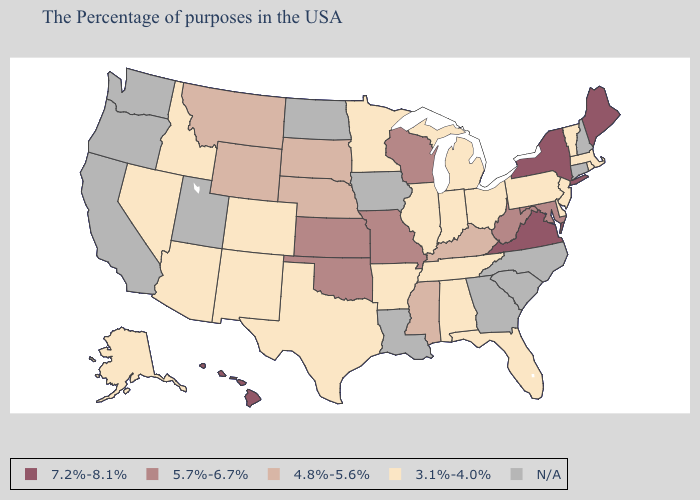Is the legend a continuous bar?
Concise answer only. No. What is the lowest value in states that border Iowa?
Write a very short answer. 3.1%-4.0%. What is the lowest value in states that border Rhode Island?
Quick response, please. 3.1%-4.0%. What is the value of Kentucky?
Keep it brief. 4.8%-5.6%. Does the first symbol in the legend represent the smallest category?
Answer briefly. No. Does Delaware have the highest value in the South?
Keep it brief. No. Name the states that have a value in the range 5.7%-6.7%?
Be succinct. Maryland, West Virginia, Wisconsin, Missouri, Kansas, Oklahoma. Name the states that have a value in the range 5.7%-6.7%?
Give a very brief answer. Maryland, West Virginia, Wisconsin, Missouri, Kansas, Oklahoma. Name the states that have a value in the range 5.7%-6.7%?
Short answer required. Maryland, West Virginia, Wisconsin, Missouri, Kansas, Oklahoma. What is the value of Kansas?
Short answer required. 5.7%-6.7%. Does the map have missing data?
Quick response, please. Yes. Which states hav the highest value in the Northeast?
Keep it brief. Maine, New York. Does the first symbol in the legend represent the smallest category?
Give a very brief answer. No. 